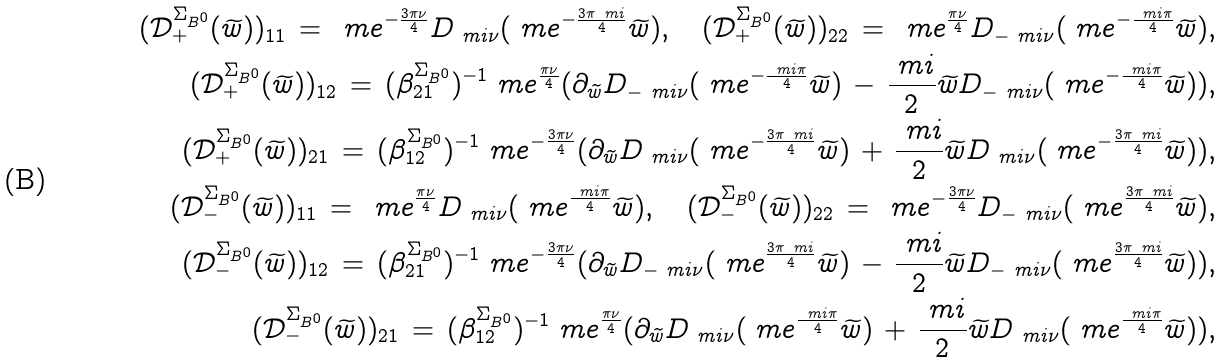Convert formula to latex. <formula><loc_0><loc_0><loc_500><loc_500>( \mathcal { D } ^ { \Sigma _ { B ^ { 0 } } } _ { + } ( \widetilde { w } ) ) _ { 1 1 } \, = \, \ m e ^ { - \frac { 3 \pi \nu } { 4 } } D _ { \ m i \nu } ( \ m e ^ { - \frac { 3 \pi \ m i } { 4 } } \widetilde { w } ) , \quad ( \mathcal { D } ^ { \Sigma _ { B ^ { 0 } } } _ { + } ( \widetilde { w } ) ) _ { 2 2 } \, = \, \ m e ^ { \frac { \pi \nu } { 4 } } D _ { - \ m i \nu } ( \ m e ^ { - \frac { \ m i \pi } { 4 } } \widetilde { w } ) , \\ ( \mathcal { D } ^ { \Sigma _ { B ^ { 0 } } } _ { + } ( \widetilde { w } ) ) _ { 1 2 } \, = \, ( \beta ^ { \Sigma _ { B ^ { 0 } } } _ { 2 1 } ) ^ { - 1 } \ m e ^ { \frac { \pi \nu } { 4 } } ( \partial _ { \widetilde { w } } D _ { - \ m i \nu } ( \ m e ^ { - \frac { \ m i \pi } { 4 } } \widetilde { w } ) \, - \, \frac { \ m i } { 2 } \widetilde { w } D _ { - \ m i \nu } ( \ m e ^ { - \frac { \ m i \pi } { 4 } } \widetilde { w } ) ) , \\ ( \mathcal { D } ^ { \Sigma _ { B ^ { 0 } } } _ { + } ( \widetilde { w } ) ) _ { 2 1 } \, = \, ( \beta ^ { \Sigma _ { B ^ { 0 } } } _ { 1 2 } ) ^ { - 1 } \ m e ^ { - \frac { 3 \pi \nu } { 4 } } ( \partial _ { \widetilde { w } } D _ { \ m i \nu } ( \ m e ^ { - \frac { 3 \pi \ m i } { 4 } } \widetilde { w } ) \, + \, \frac { \ m i } { 2 } \widetilde { w } D _ { \ m i \nu } ( \ m e ^ { - \frac { 3 \pi \ m i } { 4 } } \widetilde { w } ) ) , \\ ( \mathcal { D } ^ { \Sigma _ { B ^ { 0 } } } _ { - } ( \widetilde { w } ) ) _ { 1 1 } \, = \, \ m e ^ { \frac { \pi \nu } { 4 } } D _ { \ m i \nu } ( \ m e ^ { \frac { \ m i \pi } { 4 } } \widetilde { w } ) , \quad ( \mathcal { D } ^ { \Sigma _ { B ^ { 0 } } } _ { - } ( \widetilde { w } ) ) _ { 2 2 } \, = \, \ m e ^ { - \frac { 3 \pi \nu } { 4 } } D _ { - \ m i \nu } ( \ m e ^ { \frac { 3 \pi \ m i } { 4 } } \widetilde { w } ) , \\ ( \mathcal { D } ^ { \Sigma _ { B ^ { 0 } } } _ { - } ( \widetilde { w } ) ) _ { 1 2 } \, = \, ( \beta ^ { \Sigma _ { B ^ { 0 } } } _ { 2 1 } ) ^ { - 1 } \ m e ^ { - \frac { 3 \pi \nu } { 4 } } ( \partial _ { \widetilde { w } } D _ { - \ m i \nu } ( \ m e ^ { \frac { 3 \pi \ m i } { 4 } } \widetilde { w } ) \, - \, \frac { \ m i } { 2 } \widetilde { w } D _ { - \ m i \nu } ( \ m e ^ { \frac { 3 \pi \ m i } { 4 } } \widetilde { w } ) ) , \\ ( \mathcal { D } ^ { \Sigma _ { B ^ { 0 } } } _ { - } ( \widetilde { w } ) ) _ { 2 1 } \, = \, ( \beta ^ { \Sigma _ { B ^ { 0 } } } _ { 1 2 } ) ^ { - 1 } \ m e ^ { \frac { \pi \nu } { 4 } } ( \partial _ { \widetilde { w } } D _ { \ m i \nu } ( \ m e ^ { \frac { \ m i \pi } { 4 } } \widetilde { w } ) \, + \, \frac { \ m i } { 2 } \widetilde { w } D _ { \ m i \nu } ( \ m e ^ { \frac { \ m i \pi } { 4 } } \widetilde { w } ) ) ,</formula> 